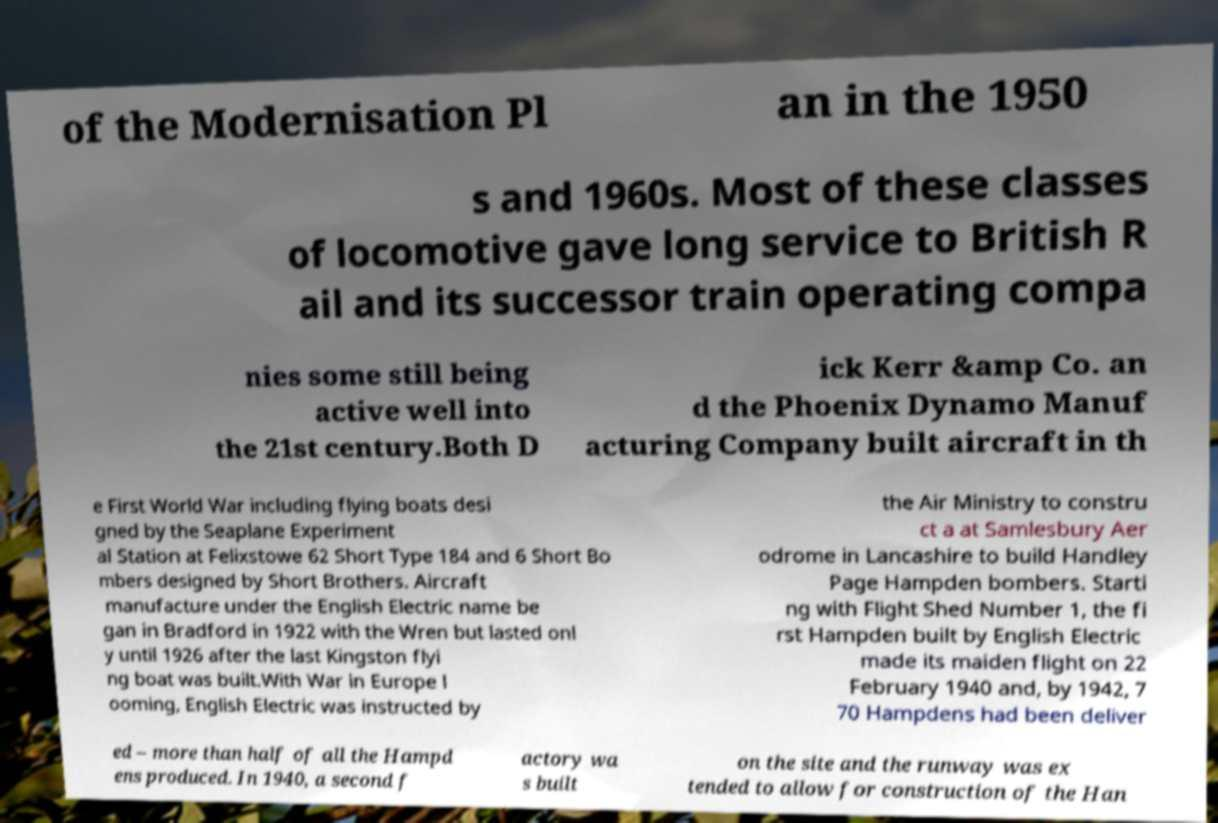I need the written content from this picture converted into text. Can you do that? of the Modernisation Pl an in the 1950 s and 1960s. Most of these classes of locomotive gave long service to British R ail and its successor train operating compa nies some still being active well into the 21st century.Both D ick Kerr &amp Co. an d the Phoenix Dynamo Manuf acturing Company built aircraft in th e First World War including flying boats desi gned by the Seaplane Experiment al Station at Felixstowe 62 Short Type 184 and 6 Short Bo mbers designed by Short Brothers. Aircraft manufacture under the English Electric name be gan in Bradford in 1922 with the Wren but lasted onl y until 1926 after the last Kingston flyi ng boat was built.With War in Europe l ooming, English Electric was instructed by the Air Ministry to constru ct a at Samlesbury Aer odrome in Lancashire to build Handley Page Hampden bombers. Starti ng with Flight Shed Number 1, the fi rst Hampden built by English Electric made its maiden flight on 22 February 1940 and, by 1942, 7 70 Hampdens had been deliver ed – more than half of all the Hampd ens produced. In 1940, a second f actory wa s built on the site and the runway was ex tended to allow for construction of the Han 